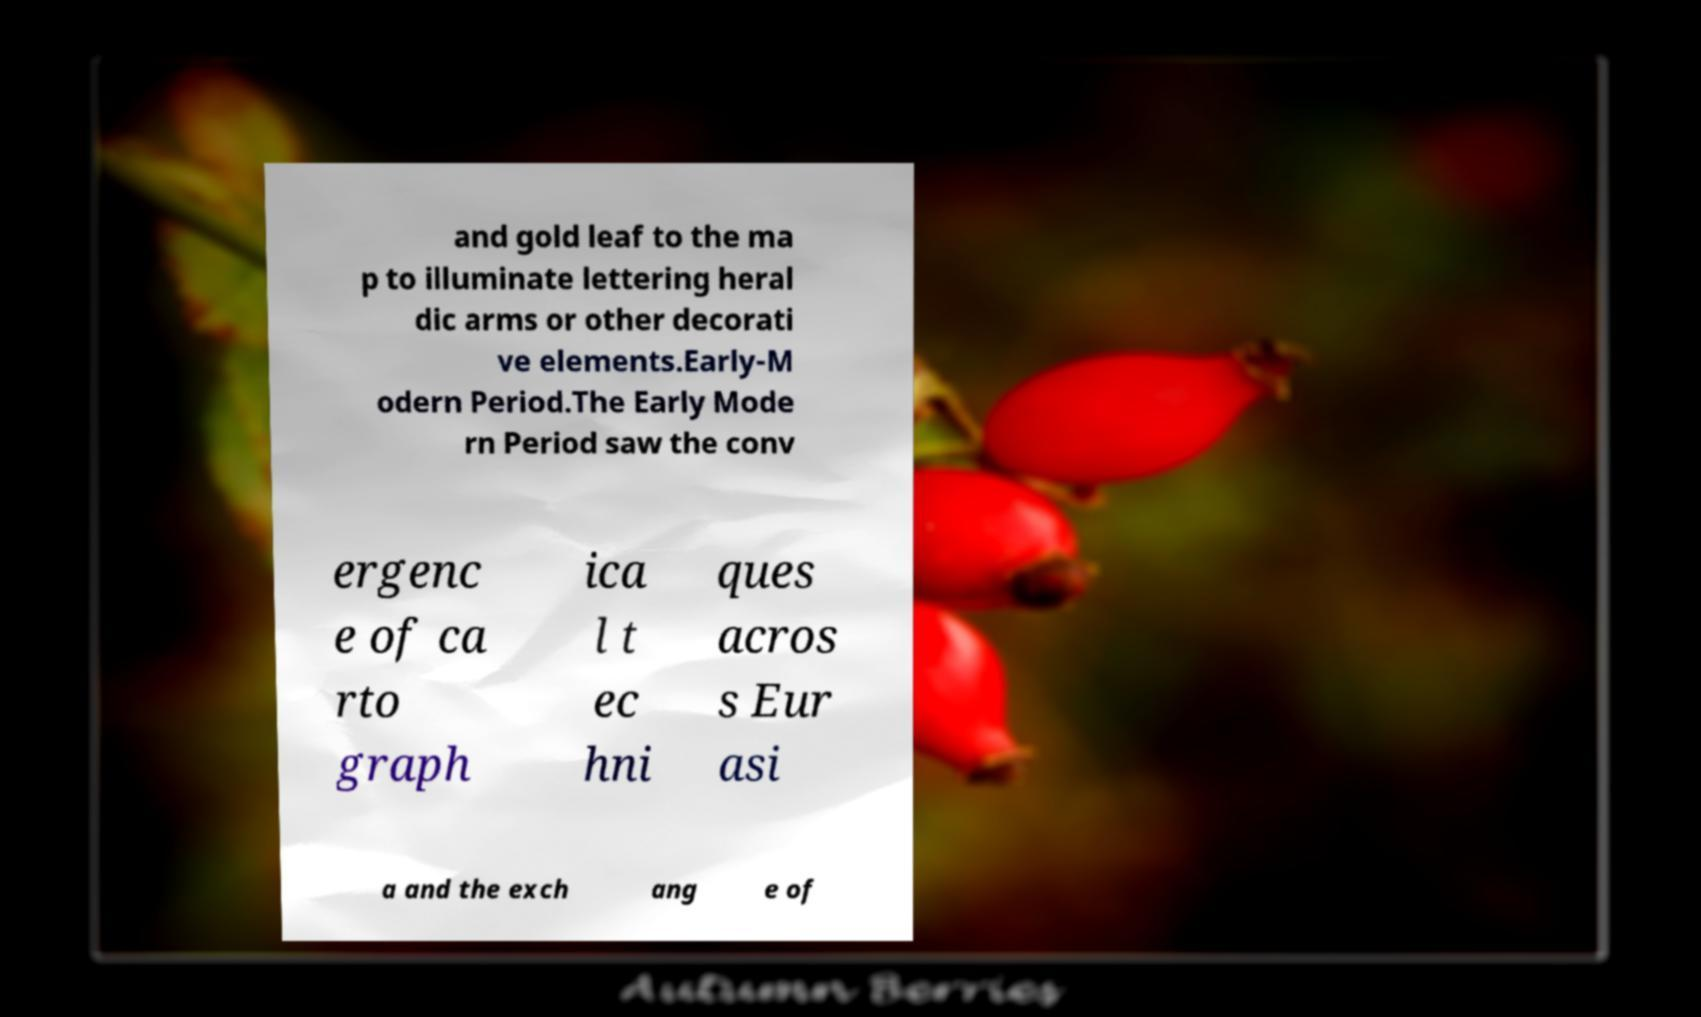Please read and relay the text visible in this image. What does it say? and gold leaf to the ma p to illuminate lettering heral dic arms or other decorati ve elements.Early-M odern Period.The Early Mode rn Period saw the conv ergenc e of ca rto graph ica l t ec hni ques acros s Eur asi a and the exch ang e of 